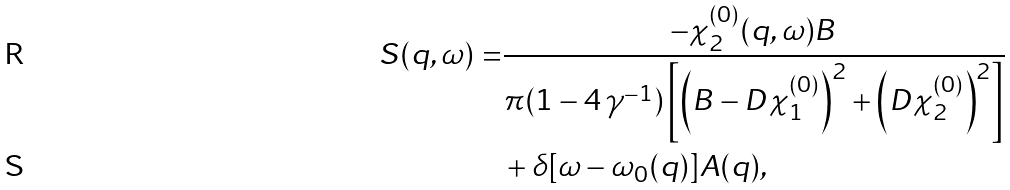<formula> <loc_0><loc_0><loc_500><loc_500>S ( q , \omega ) = & \frac { - \chi ^ { ( 0 ) } _ { 2 } ( q , \omega ) B } { \pi ( 1 - 4 \, \gamma ^ { - 1 } ) \left [ \left ( B - D \chi _ { 1 } ^ { ( 0 ) } \right ) ^ { 2 } + \left ( D \chi _ { 2 } ^ { ( 0 ) } \right ) ^ { 2 } \right ] } \\ & + \delta [ \omega - \omega _ { 0 } ( q ) ] A ( q ) ,</formula> 